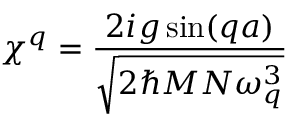Convert formula to latex. <formula><loc_0><loc_0><loc_500><loc_500>\chi ^ { q } = \frac { 2 i g \sin ( q a ) } { \sqrt { 2 \hbar { M } N \omega _ { q } ^ { 3 } } }</formula> 